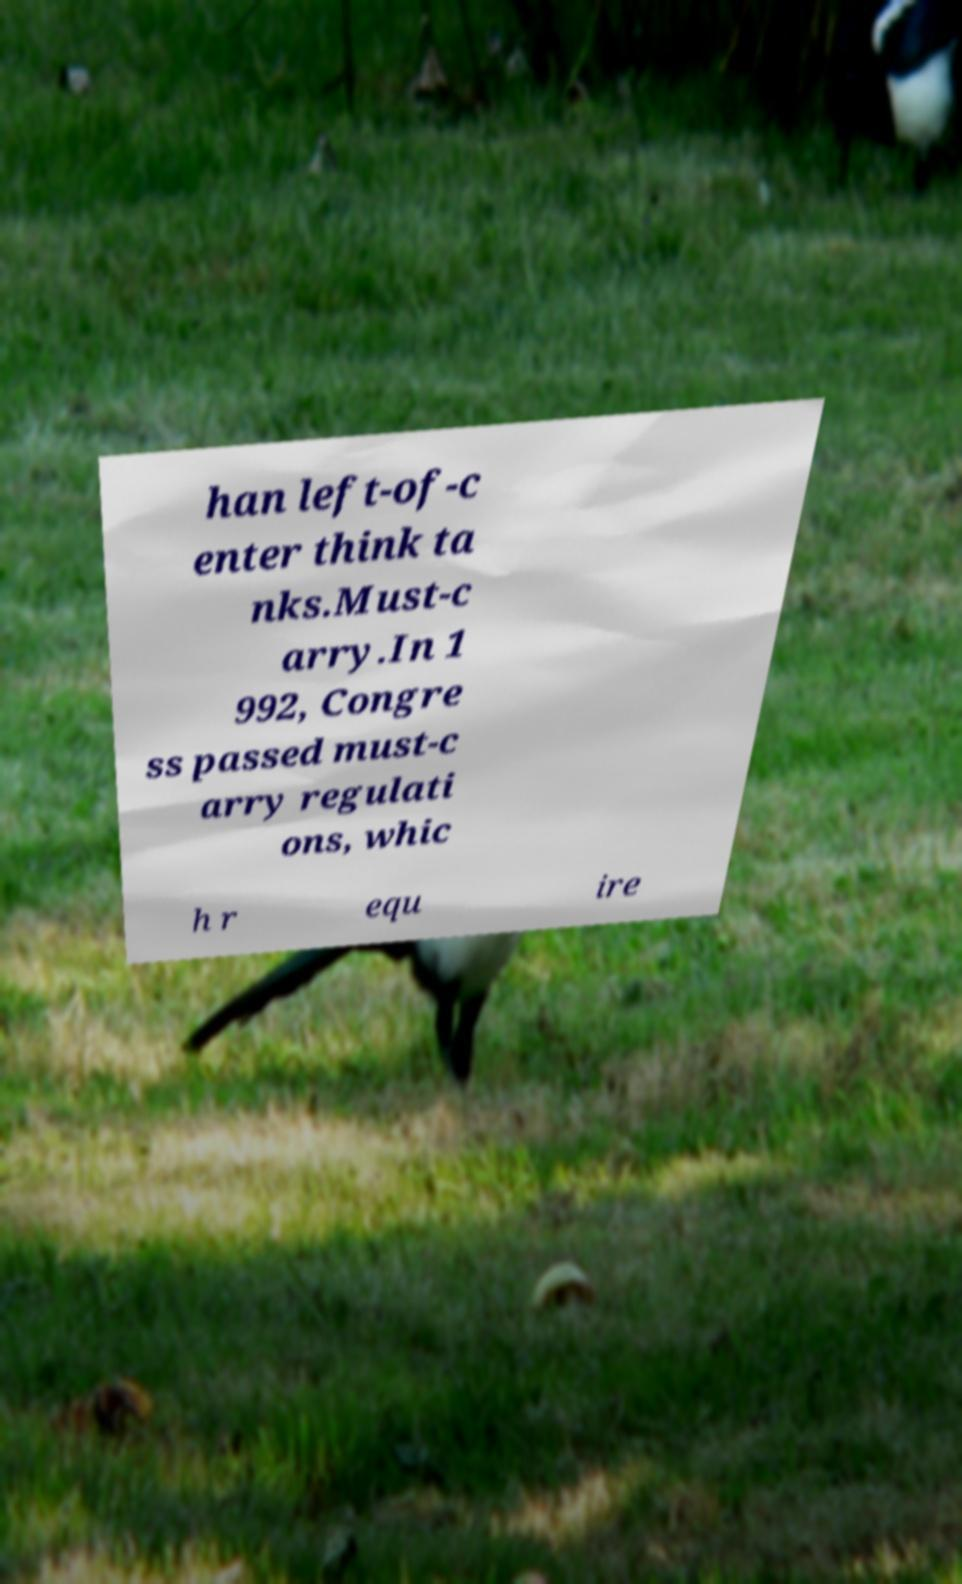Could you assist in decoding the text presented in this image and type it out clearly? han left-of-c enter think ta nks.Must-c arry.In 1 992, Congre ss passed must-c arry regulati ons, whic h r equ ire 